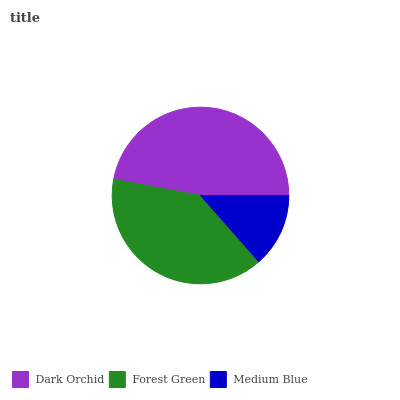Is Medium Blue the minimum?
Answer yes or no. Yes. Is Dark Orchid the maximum?
Answer yes or no. Yes. Is Forest Green the minimum?
Answer yes or no. No. Is Forest Green the maximum?
Answer yes or no. No. Is Dark Orchid greater than Forest Green?
Answer yes or no. Yes. Is Forest Green less than Dark Orchid?
Answer yes or no. Yes. Is Forest Green greater than Dark Orchid?
Answer yes or no. No. Is Dark Orchid less than Forest Green?
Answer yes or no. No. Is Forest Green the high median?
Answer yes or no. Yes. Is Forest Green the low median?
Answer yes or no. Yes. Is Medium Blue the high median?
Answer yes or no. No. Is Medium Blue the low median?
Answer yes or no. No. 